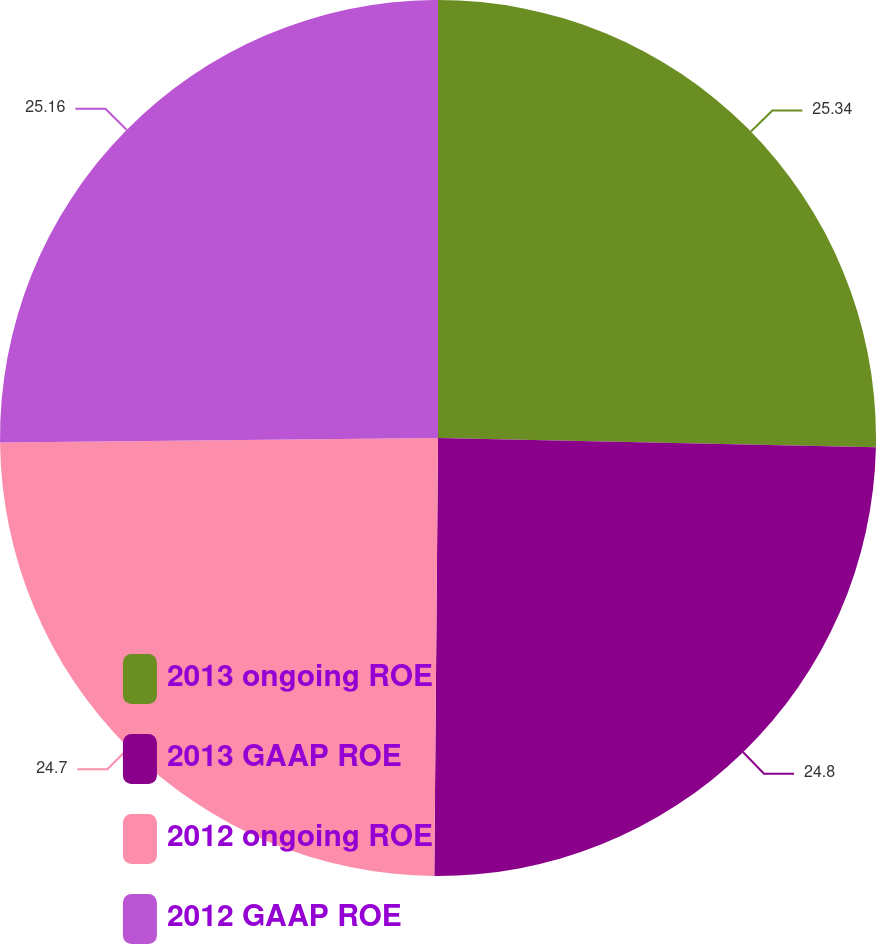Convert chart to OTSL. <chart><loc_0><loc_0><loc_500><loc_500><pie_chart><fcel>2013 ongoing ROE<fcel>2013 GAAP ROE<fcel>2012 ongoing ROE<fcel>2012 GAAP ROE<nl><fcel>25.33%<fcel>24.8%<fcel>24.7%<fcel>25.16%<nl></chart> 